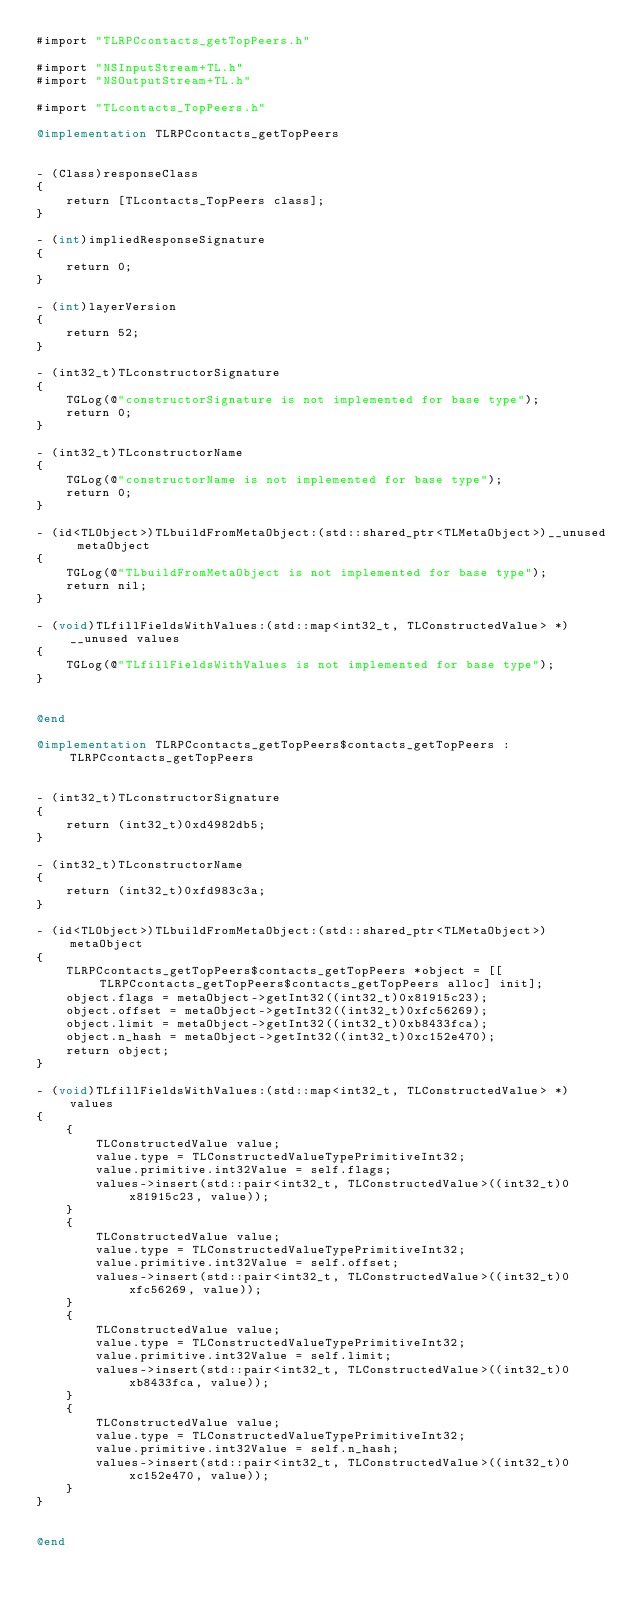<code> <loc_0><loc_0><loc_500><loc_500><_ObjectiveC_>#import "TLRPCcontacts_getTopPeers.h"

#import "NSInputStream+TL.h"
#import "NSOutputStream+TL.h"

#import "TLcontacts_TopPeers.h"

@implementation TLRPCcontacts_getTopPeers


- (Class)responseClass
{
    return [TLcontacts_TopPeers class];
}

- (int)impliedResponseSignature
{
    return 0;
}

- (int)layerVersion
{
    return 52;
}

- (int32_t)TLconstructorSignature
{
    TGLog(@"constructorSignature is not implemented for base type");
    return 0;
}

- (int32_t)TLconstructorName
{
    TGLog(@"constructorName is not implemented for base type");
    return 0;
}

- (id<TLObject>)TLbuildFromMetaObject:(std::shared_ptr<TLMetaObject>)__unused metaObject
{
    TGLog(@"TLbuildFromMetaObject is not implemented for base type");
    return nil;
}

- (void)TLfillFieldsWithValues:(std::map<int32_t, TLConstructedValue> *)__unused values
{
    TGLog(@"TLfillFieldsWithValues is not implemented for base type");
}


@end

@implementation TLRPCcontacts_getTopPeers$contacts_getTopPeers : TLRPCcontacts_getTopPeers


- (int32_t)TLconstructorSignature
{
    return (int32_t)0xd4982db5;
}

- (int32_t)TLconstructorName
{
    return (int32_t)0xfd983c3a;
}

- (id<TLObject>)TLbuildFromMetaObject:(std::shared_ptr<TLMetaObject>)metaObject
{
    TLRPCcontacts_getTopPeers$contacts_getTopPeers *object = [[TLRPCcontacts_getTopPeers$contacts_getTopPeers alloc] init];
    object.flags = metaObject->getInt32((int32_t)0x81915c23);
    object.offset = metaObject->getInt32((int32_t)0xfc56269);
    object.limit = metaObject->getInt32((int32_t)0xb8433fca);
    object.n_hash = metaObject->getInt32((int32_t)0xc152e470);
    return object;
}

- (void)TLfillFieldsWithValues:(std::map<int32_t, TLConstructedValue> *)values
{
    {
        TLConstructedValue value;
        value.type = TLConstructedValueTypePrimitiveInt32;
        value.primitive.int32Value = self.flags;
        values->insert(std::pair<int32_t, TLConstructedValue>((int32_t)0x81915c23, value));
    }
    {
        TLConstructedValue value;
        value.type = TLConstructedValueTypePrimitiveInt32;
        value.primitive.int32Value = self.offset;
        values->insert(std::pair<int32_t, TLConstructedValue>((int32_t)0xfc56269, value));
    }
    {
        TLConstructedValue value;
        value.type = TLConstructedValueTypePrimitiveInt32;
        value.primitive.int32Value = self.limit;
        values->insert(std::pair<int32_t, TLConstructedValue>((int32_t)0xb8433fca, value));
    }
    {
        TLConstructedValue value;
        value.type = TLConstructedValueTypePrimitiveInt32;
        value.primitive.int32Value = self.n_hash;
        values->insert(std::pair<int32_t, TLConstructedValue>((int32_t)0xc152e470, value));
    }
}


@end

</code> 